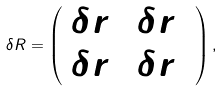<formula> <loc_0><loc_0><loc_500><loc_500>\delta R = \left ( \begin{array} { c r c } { { \delta r _ { 1 } } } & { { \delta r _ { 3 } } } \\ { { \delta r _ { 3 } } } & { { \delta r _ { 2 } } } \end{array} \right ) ,</formula> 